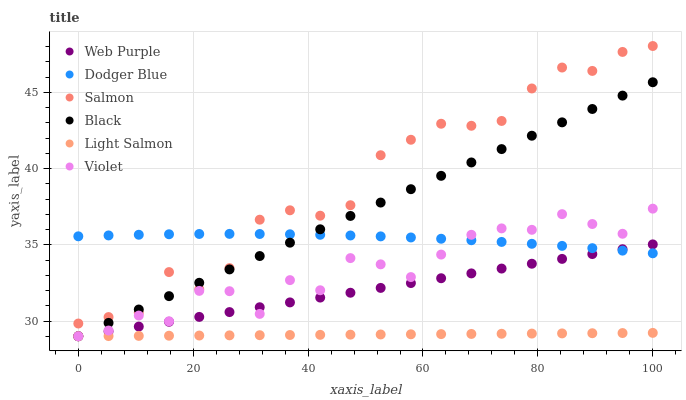Does Light Salmon have the minimum area under the curve?
Answer yes or no. Yes. Does Salmon have the maximum area under the curve?
Answer yes or no. Yes. Does Web Purple have the minimum area under the curve?
Answer yes or no. No. Does Web Purple have the maximum area under the curve?
Answer yes or no. No. Is Light Salmon the smoothest?
Answer yes or no. Yes. Is Violet the roughest?
Answer yes or no. Yes. Is Salmon the smoothest?
Answer yes or no. No. Is Salmon the roughest?
Answer yes or no. No. Does Light Salmon have the lowest value?
Answer yes or no. Yes. Does Salmon have the lowest value?
Answer yes or no. No. Does Salmon have the highest value?
Answer yes or no. Yes. Does Web Purple have the highest value?
Answer yes or no. No. Is Violet less than Salmon?
Answer yes or no. Yes. Is Salmon greater than Web Purple?
Answer yes or no. Yes. Does Dodger Blue intersect Salmon?
Answer yes or no. Yes. Is Dodger Blue less than Salmon?
Answer yes or no. No. Is Dodger Blue greater than Salmon?
Answer yes or no. No. Does Violet intersect Salmon?
Answer yes or no. No. 